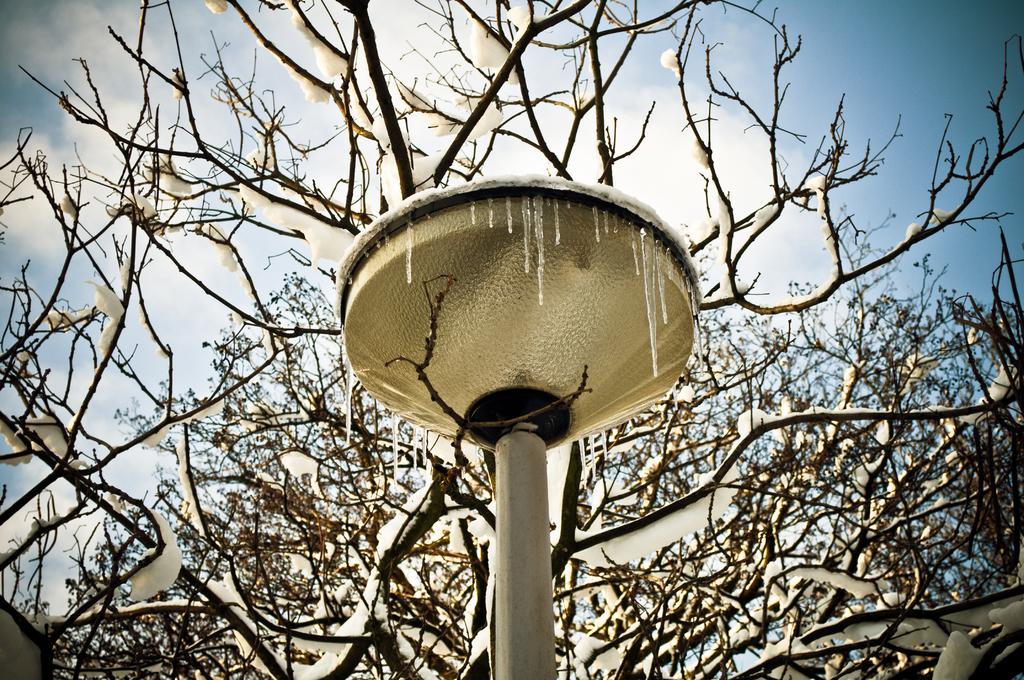Could you give a brief overview of what you see in this image? In this picture we can see a pole and trees and in the background we can see the sky. 